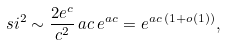Convert formula to latex. <formula><loc_0><loc_0><loc_500><loc_500>\ s i ^ { 2 } \sim \frac { 2 e ^ { c } } { c ^ { 2 } } \, a c \, e ^ { a c } = e ^ { a c \, ( 1 + o ( 1 ) ) } ,</formula> 